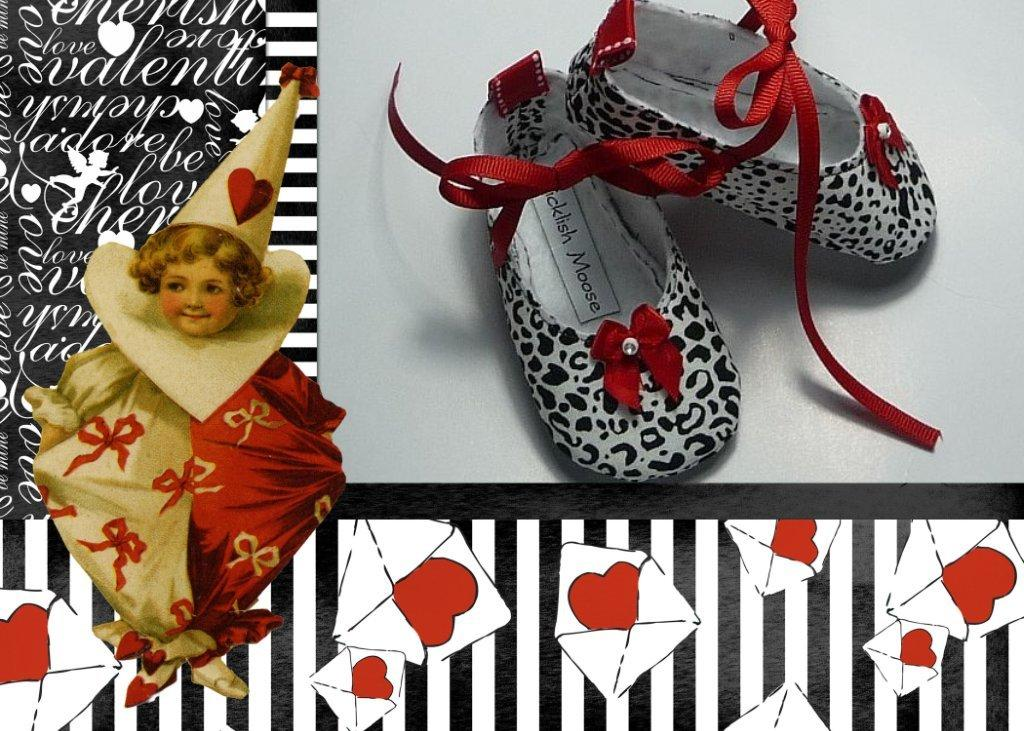What is the main object in the image? There is a doll in the image. What else can be seen in the image besides the doll? There is a pair of footwear in the image. What is the color of the surface the doll and footwear are on? The surface they are on appears to be white. Where is the text located in the image? The text is on the left side of the image. What type of quiver is visible in the image? There is no quiver present in the image. How does the doll show care for the footwear in the image? The doll does not show care for the footwear in the image; it is an inanimate object. 